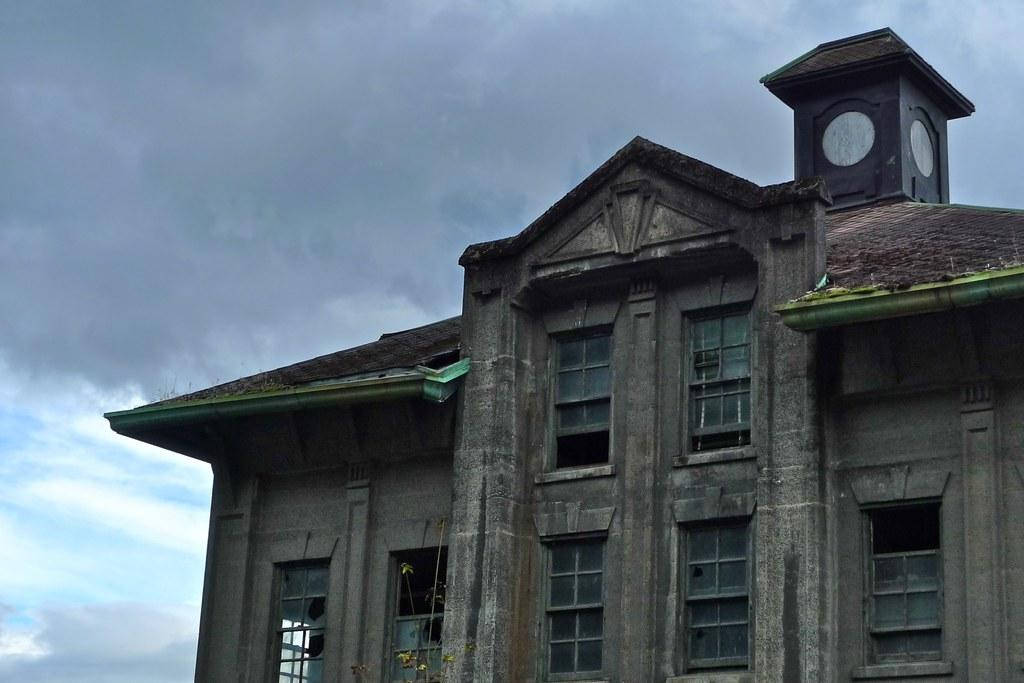What is the main structure in the center of the image? There is a building in the center of the image. What are the main components of the building? The building has a roof, walls, and windows. What else can be seen in the image besides the building? There is a plant in the image. What is visible in the background of the image? The sky is visible in the background of the image, and there are clouds in the sky. Where is the net located in the image? There is no net present in the image. What knowledge can be gained from the sink in the image? There is no sink present in the image, so no knowledge can be gained from it. 